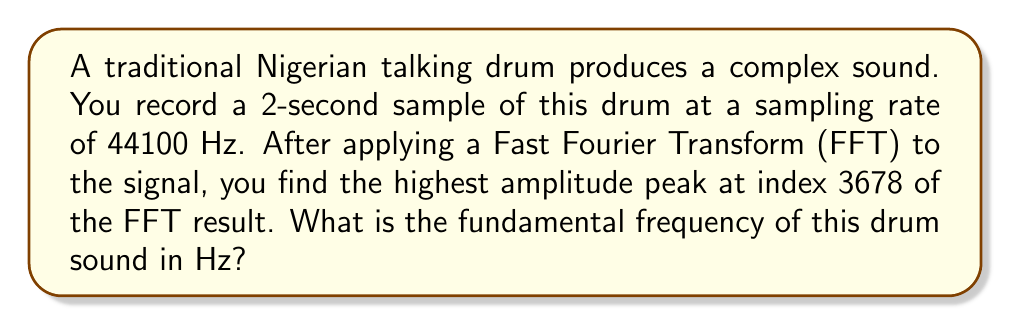Help me with this question. To solve this problem, we'll follow these steps:

1) First, we need to understand the relationship between the FFT result and frequency. The FFT converts a time-domain signal into a frequency-domain representation. The index of each FFT result corresponds to a specific frequency.

2) The frequency resolution of the FFT is given by:

   $$\Delta f = \frac{f_s}{N}$$

   Where $f_s$ is the sampling frequency and $N$ is the number of samples.

3) In this case:
   $f_s = 44100$ Hz
   Duration = 2 seconds
   $N = 44100 \times 2 = 88200$ samples

4) So, the frequency resolution is:

   $$\Delta f = \frac{44100}{88200} = 0.5 \text{ Hz}$$

5) The frequency corresponding to any index $k$ in the FFT result is given by:

   $$f = k \times \Delta f$$

6) We're told that the highest amplitude peak is at index 3678. Therefore:

   $$f = 3678 \times 0.5 = 1839 \text{ Hz}$$

Thus, the fundamental frequency of the drum sound is 1839 Hz.
Answer: 1839 Hz 